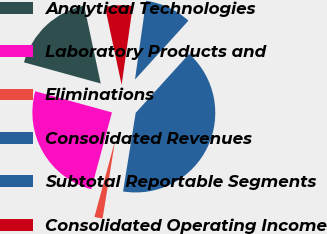Convert chart to OTSL. <chart><loc_0><loc_0><loc_500><loc_500><pie_chart><fcel>Analytical Technologies<fcel>Laboratory Products and<fcel>Eliminations<fcel>Consolidated Revenues<fcel>Subtotal Reportable Segments<fcel>Consolidated Operating Income<nl><fcel>17.38%<fcel>25.09%<fcel>1.66%<fcel>40.81%<fcel>9.49%<fcel>5.57%<nl></chart> 